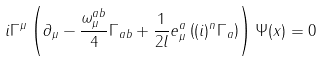Convert formula to latex. <formula><loc_0><loc_0><loc_500><loc_500>i \Gamma ^ { \mu } \left ( \partial _ { \mu } - \frac { \omega _ { \mu } ^ { a b } } { 4 } \Gamma _ { a b } + \frac { 1 } { 2 l } e _ { \mu } ^ { a } \left ( ( i ) ^ { n } \Gamma _ { a } \right ) \right ) \Psi ( x ) = 0</formula> 